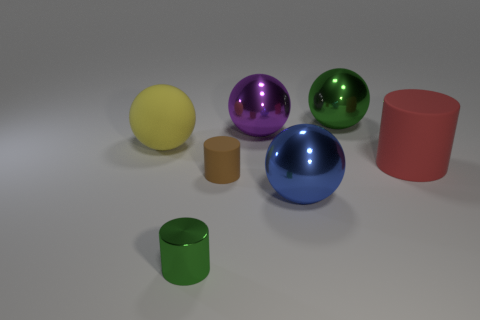Add 1 brown rubber cylinders. How many objects exist? 8 Subtract all balls. How many objects are left? 3 Subtract 0 blue cylinders. How many objects are left? 7 Subtract all tiny brown cylinders. Subtract all red cylinders. How many objects are left? 5 Add 7 big yellow spheres. How many big yellow spheres are left? 8 Add 7 brown matte things. How many brown matte things exist? 8 